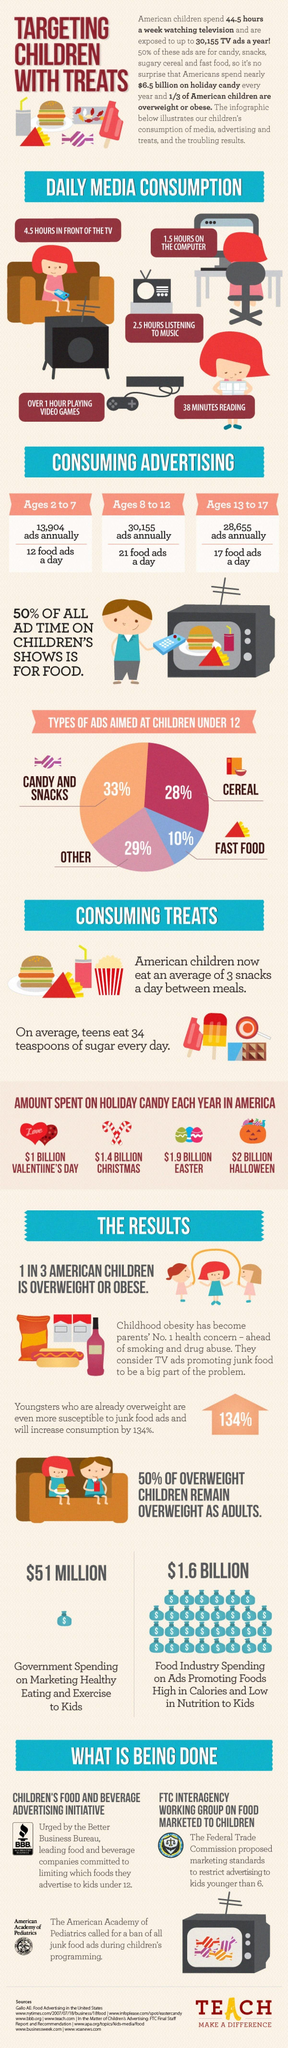How many dollars is spent by food industry on ads?
Answer the question with a short phrase. 1.6 Billion What food item does the third largest section in the pie-chart represent? Cereal How much did government spend on promoting healthy eating to kids? $ 51 million What is thought by parents as a reason for childhood obesity? TV ads promoting junk food 28,655 ads are targeted annually against children of which age group? Ages 13 to 17 Against which age group is the highest number of food ads targeted daily? Ages 8 to 12 On which holiday is more spent on candy- Christmas or Easter? Easter How many dollars are spent on candy during valentine's day? 1 Billion During which holiday is the second highest amount spent on candy? Easter How many food ads per day targeting kids 2-7 years? 12 